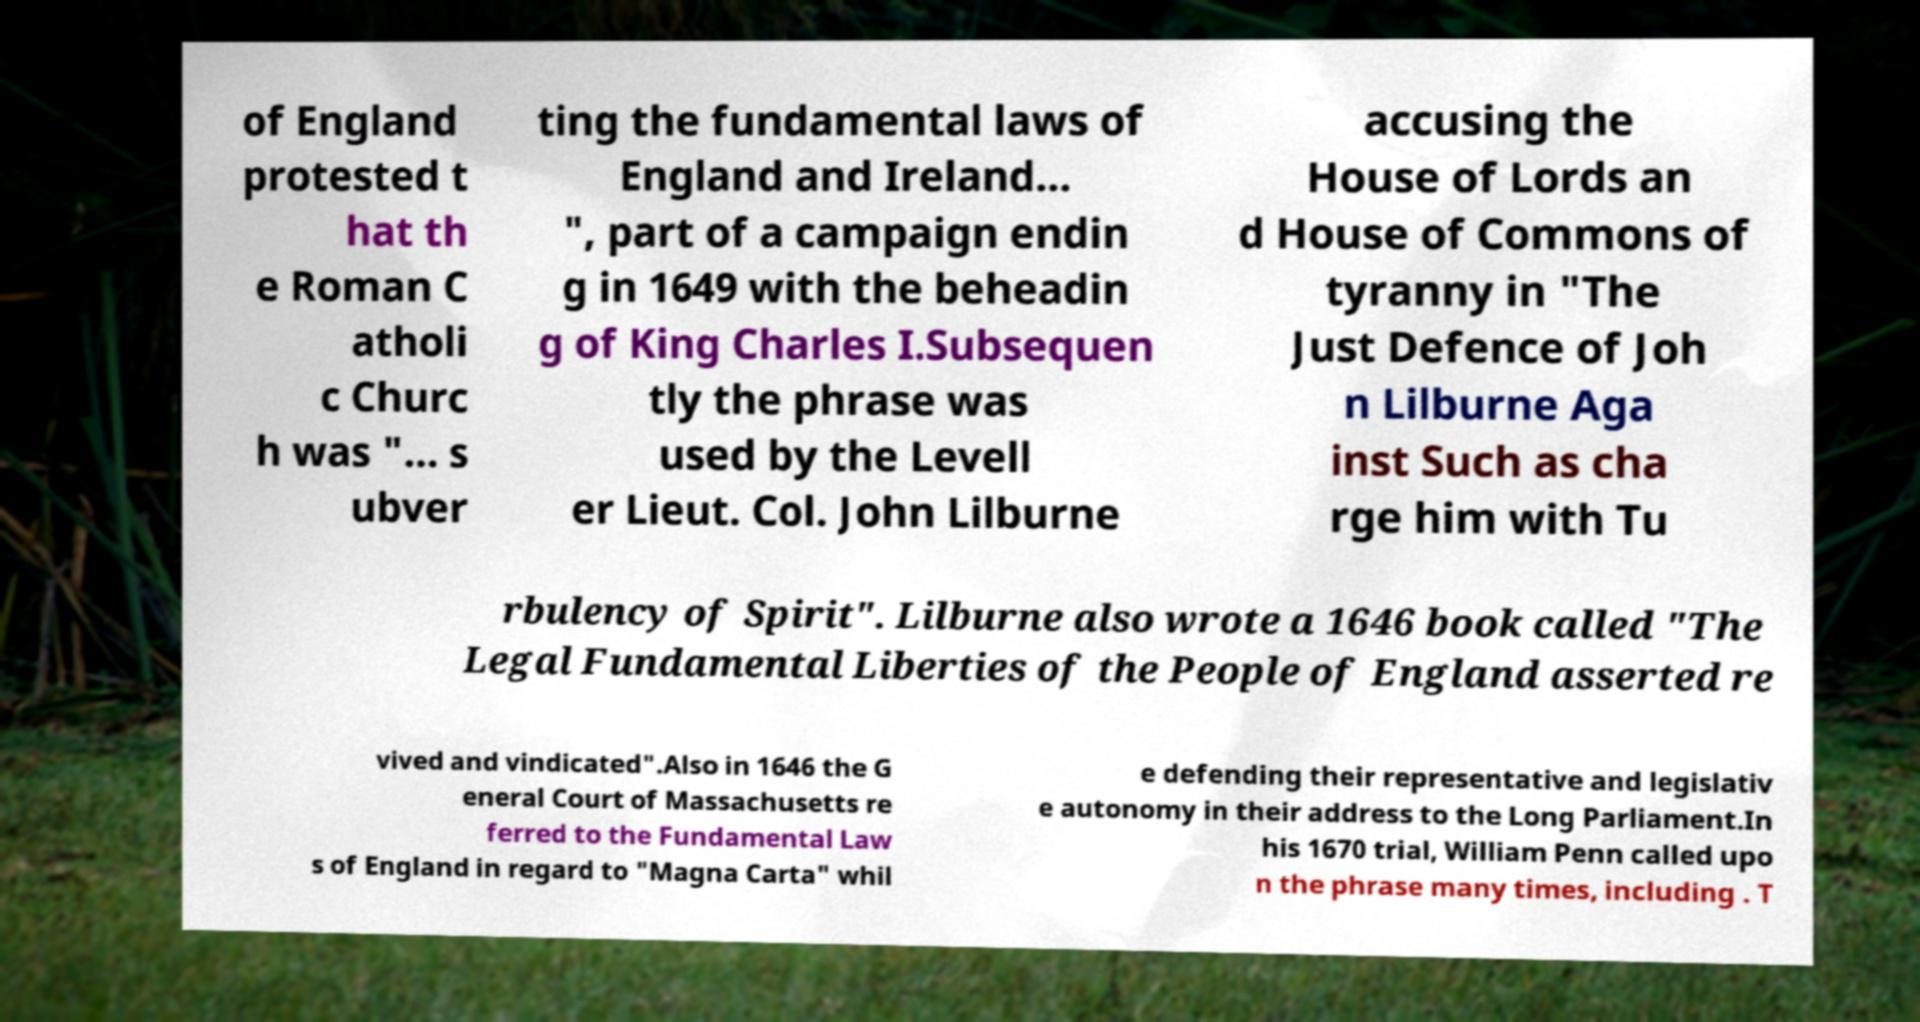Please read and relay the text visible in this image. What does it say? of England protested t hat th e Roman C atholi c Churc h was "... s ubver ting the fundamental laws of England and Ireland... ", part of a campaign endin g in 1649 with the beheadin g of King Charles I.Subsequen tly the phrase was used by the Levell er Lieut. Col. John Lilburne accusing the House of Lords an d House of Commons of tyranny in "The Just Defence of Joh n Lilburne Aga inst Such as cha rge him with Tu rbulency of Spirit". Lilburne also wrote a 1646 book called "The Legal Fundamental Liberties of the People of England asserted re vived and vindicated".Also in 1646 the G eneral Court of Massachusetts re ferred to the Fundamental Law s of England in regard to "Magna Carta" whil e defending their representative and legislativ e autonomy in their address to the Long Parliament.In his 1670 trial, William Penn called upo n the phrase many times, including . T 